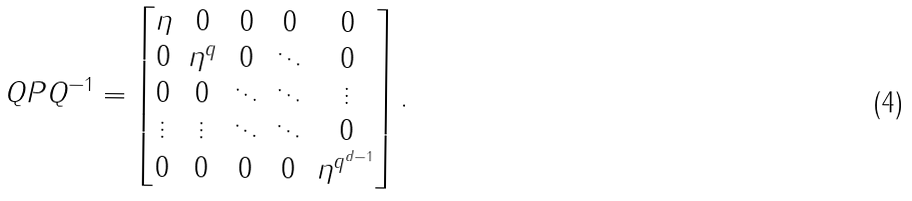<formula> <loc_0><loc_0><loc_500><loc_500>Q P Q ^ { - 1 } = \begin{bmatrix} \eta & 0 & 0 & 0 & 0 \\ 0 & \eta ^ { q } & 0 & \ddots & 0 \\ 0 & 0 & \ddots & \ddots & \vdots \\ \vdots & \vdots & \ddots & \ddots & 0 \\ 0 & 0 & 0 & 0 & \eta ^ { q ^ { d - 1 } } \\ \end{bmatrix} .</formula> 